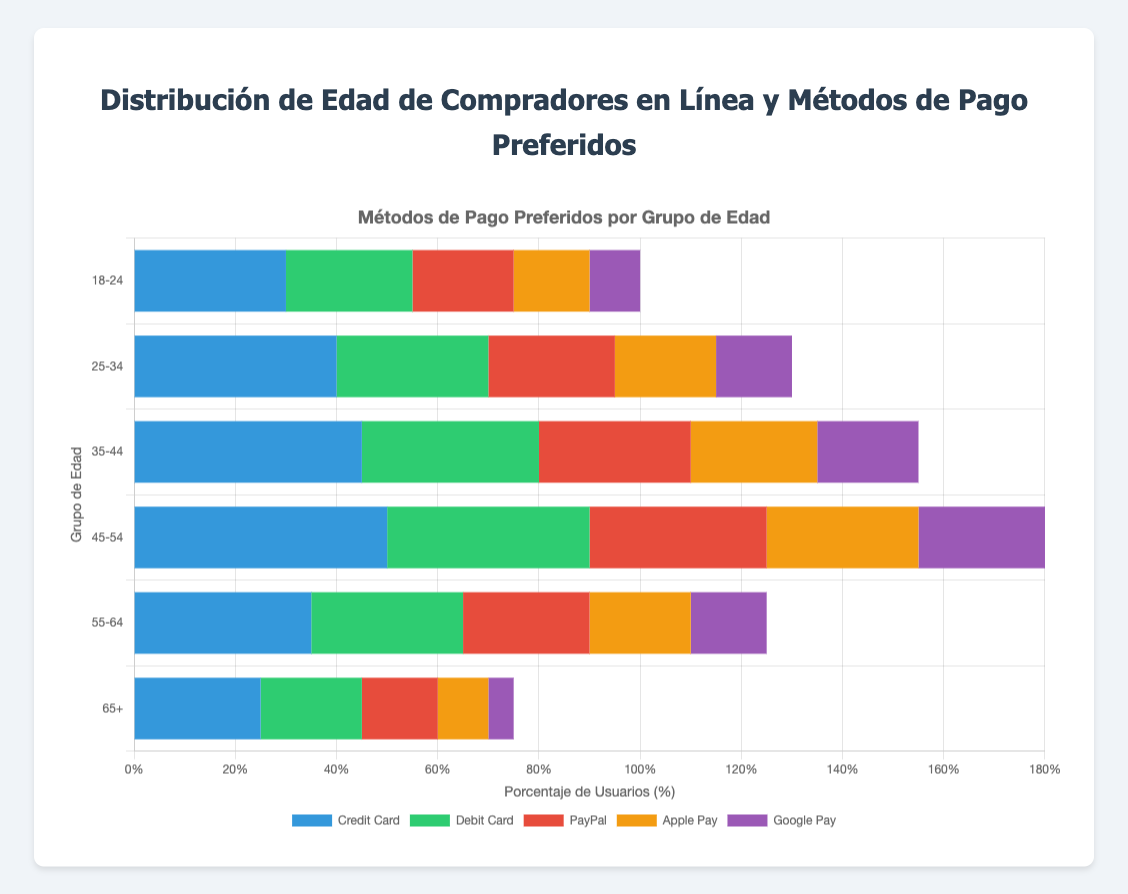What's the most popular payment method among the age group 45-54? The figure shows the number of users in the 45-54 age group for each payment method. The highest bar in this group is for "Credit Card" with 50 users.
Answer: Credit Card Which age group has the highest preference for Google Pay? The figure shows bars for Google Pay across all age groups. The age group 45-54 has the highest bar with 25 users.
Answer: 45-54 What is the total number of users in the 25-34 age group across all payment methods? Sum the values for Credit Card (40), Debit Card (30), PayPal (25), Apple Pay (20), and Google Pay (15) in the 25-34 age group: 40 + 30 + 25 + 20 + 15 = 130.
Answer: 130 Which age group shows the least preference for Apple Pay? The figure shows bars for Apple Pay across all age groups. The age group 65+ has the lowest bar with 10 users.
Answer: 65+ Compare the preference for Debit Card between the age groups 18-24 and 55-64. Which group has a higher number of users? The figure shows the number of users for Debit Card in the age groups 18-24 (25 users) and 55-64 (30 users), making 55-64 the group with a higher number of users.
Answer: 55-64 What percentage of users in the 18-24 age group prefer PayPal out of their total? The total number of users in the 18-24 age group is 30 + 25 + 20 + 15 + 10 = 100. The percentage for PayPal is (20/100) * 100 = 20%.
Answer: 20% What is the difference in the number of PayPal users between the age groups 35-44 and 65+? The number of PayPal users in the 35-44 age group is 30, and in the 65+ age group is 15. The difference is 30 - 15 = 15.
Answer: 15 Which payment method is preferred by more users in the 55-64 age group: Apple Pay or PayPal? The figure shows 55-64 age group has 20 users for Apple Pay and 25 users for PayPal. PayPal is preferred by more users.
Answer: PayPal Visualize the number of Credit Card users between the age groups 25-34 and 45-54. What can you conclude about their preferences? The data shows 25-34 has 40 users and 45-54 has 50 users for Credit Card, indicating an increasing preference for Credit Card as age increases within these groups.
Answer: Preference increases with age 